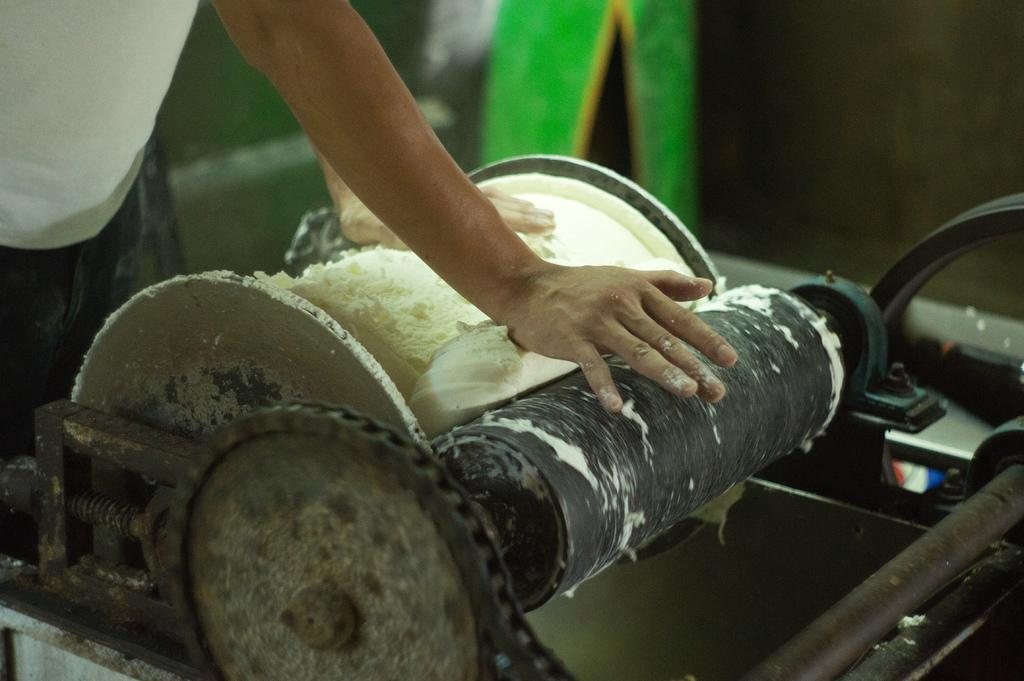Where is the person located in the image? The person is in the top left corner of the image. What is the person doing in the image? The person is standing in the image. What is the person holding in the image? The person is holding a machine in the image. What type of comb is the person using in the image? There is no comb present in the image; the person is holding a machine. What color are the jeans the person is wearing in the image? There is no information about the person's clothing in the image, so we cannot determine the color of their jeans. 